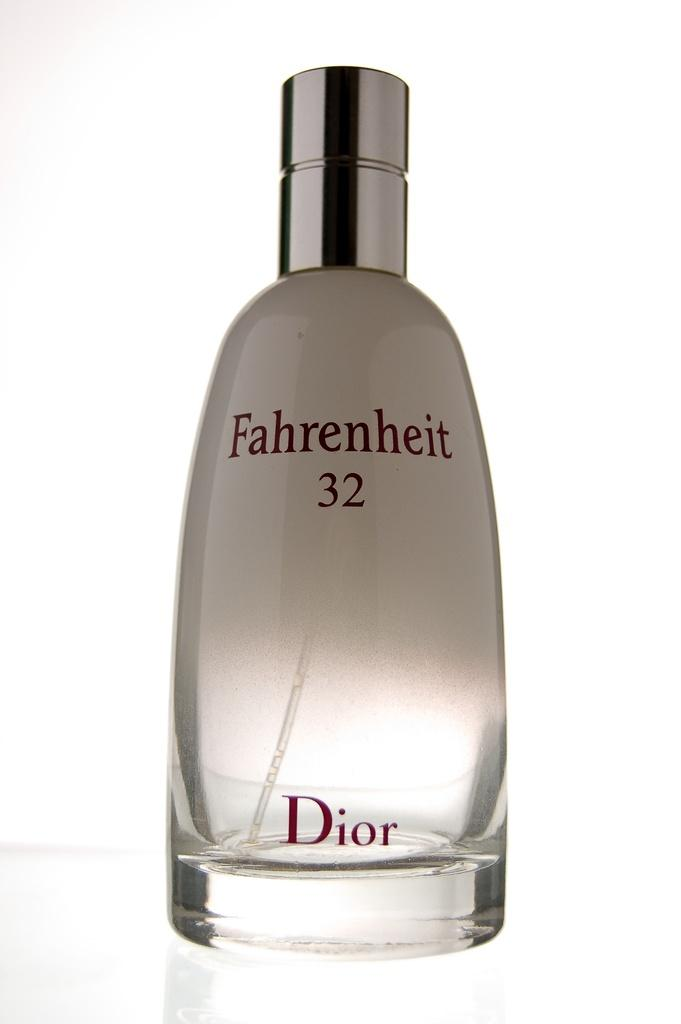<image>
Relay a brief, clear account of the picture shown. A Dior fragrance loosely references a famous novel. 